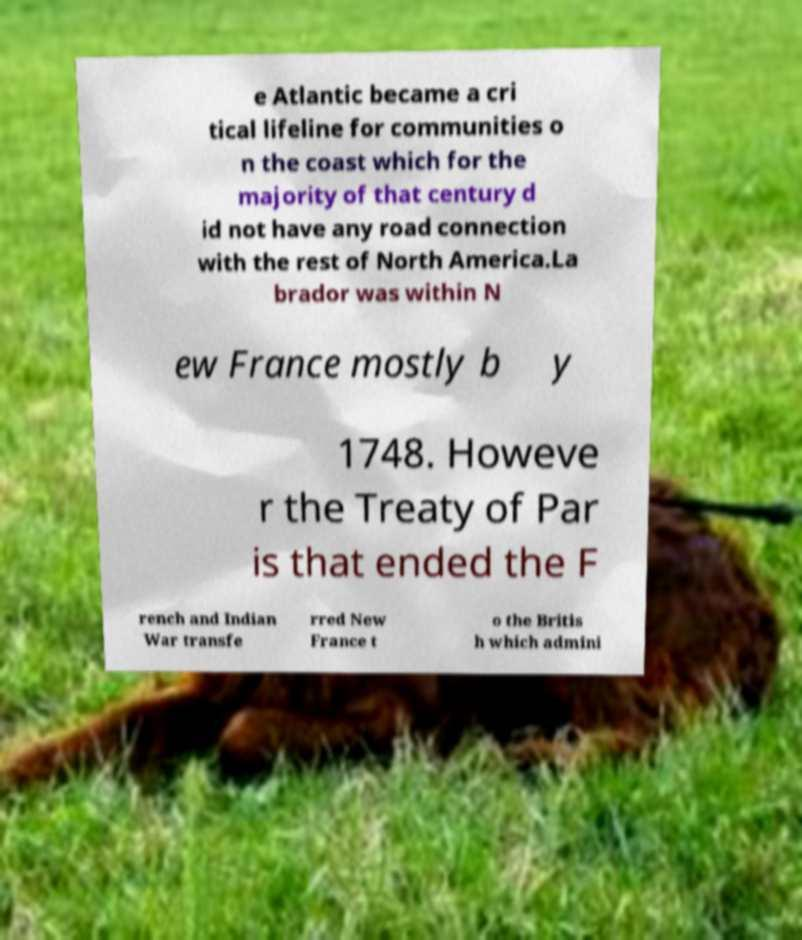Please read and relay the text visible in this image. What does it say? e Atlantic became a cri tical lifeline for communities o n the coast which for the majority of that century d id not have any road connection with the rest of North America.La brador was within N ew France mostly b y 1748. Howeve r the Treaty of Par is that ended the F rench and Indian War transfe rred New France t o the Britis h which admini 